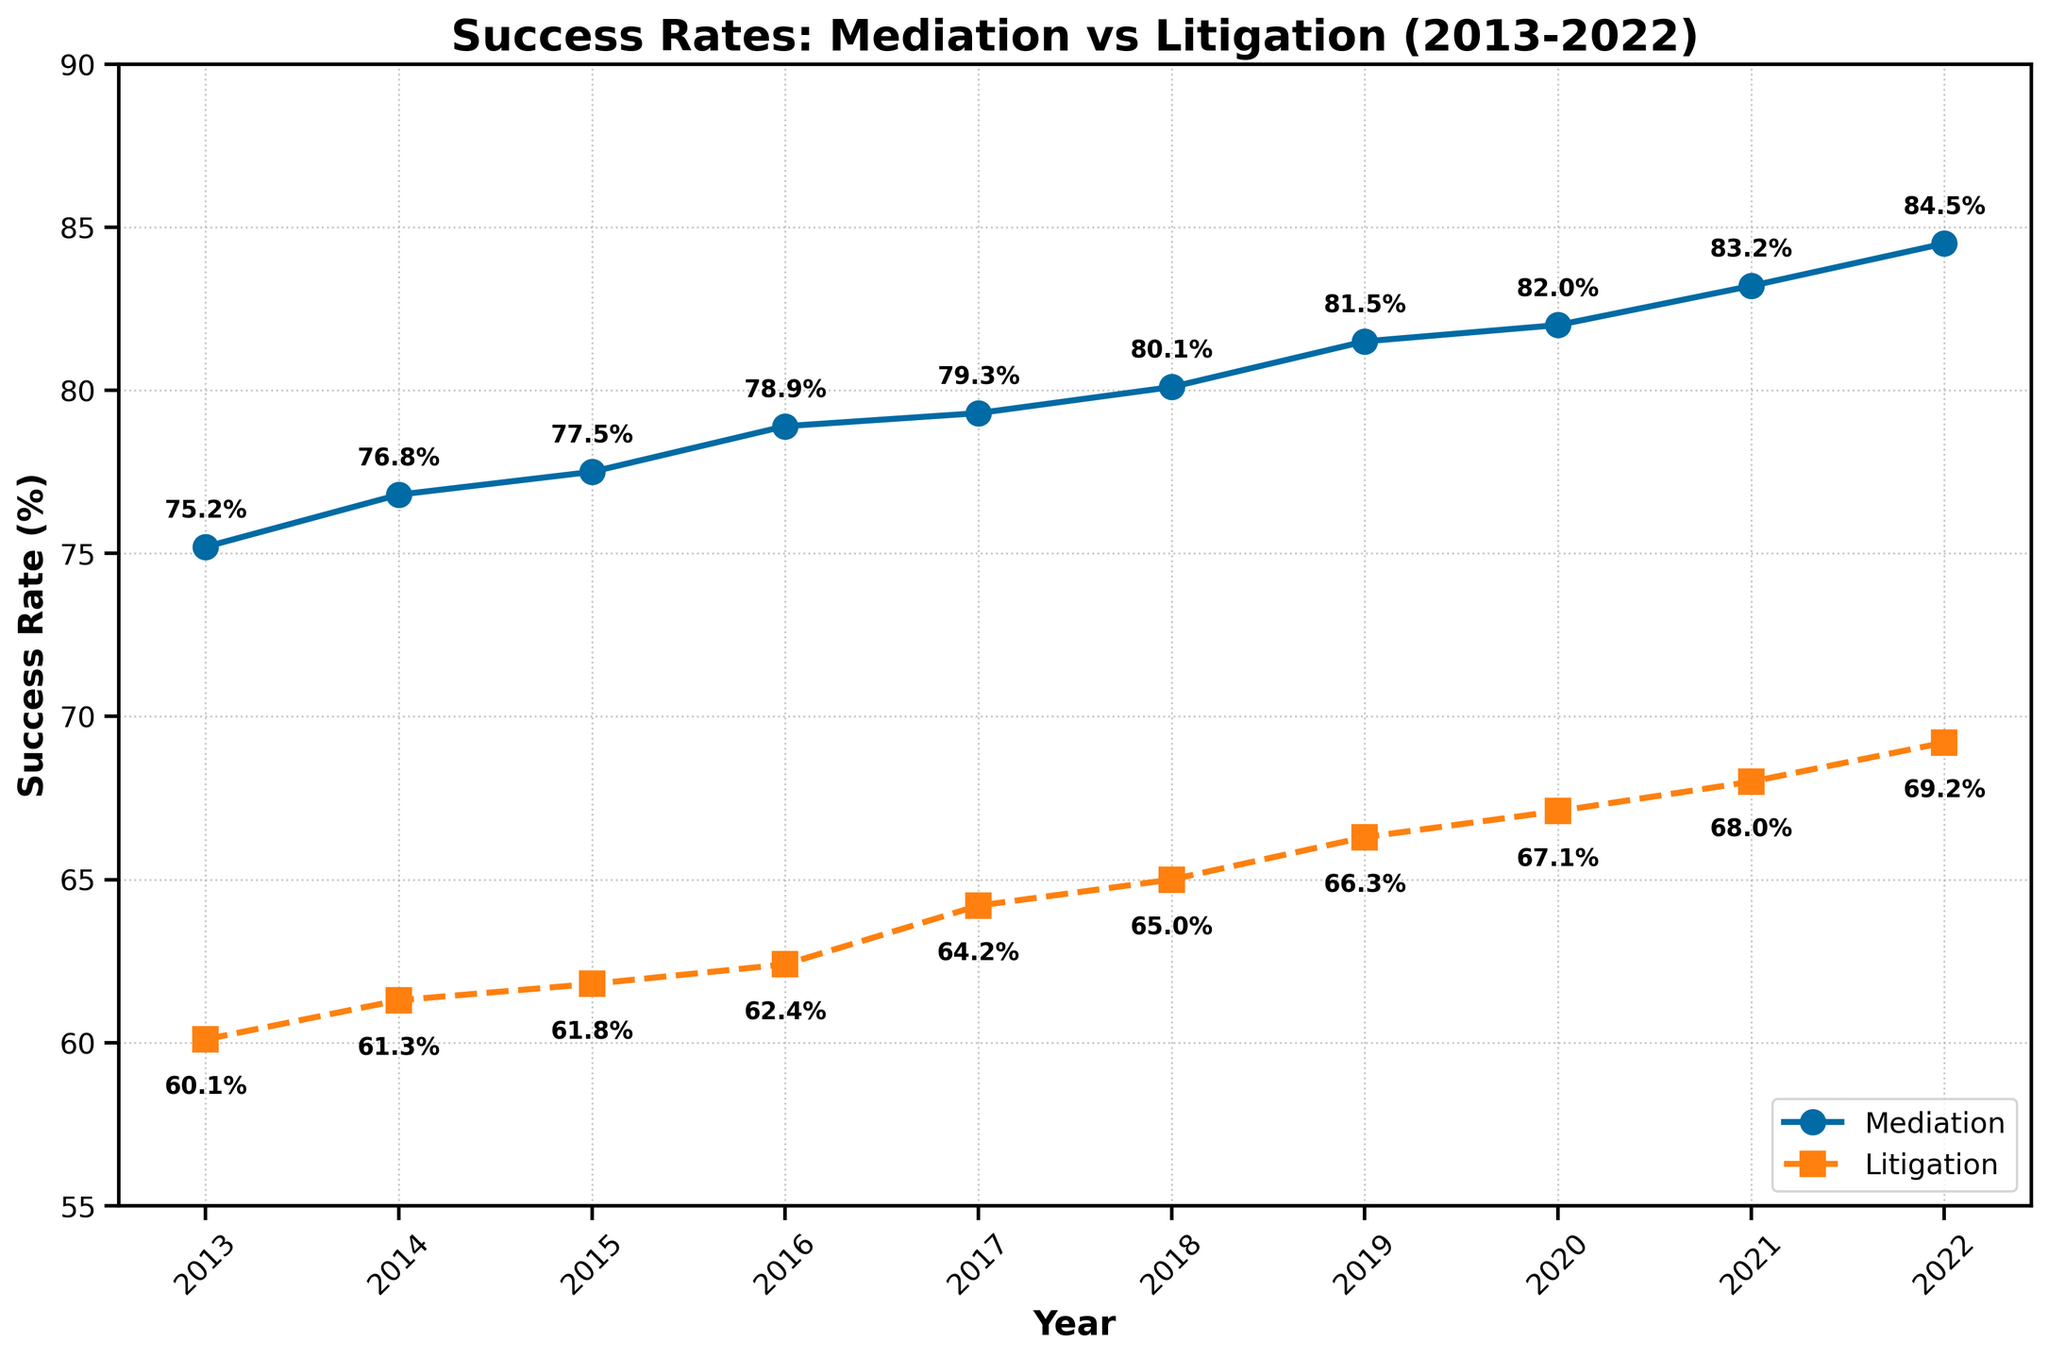what year has the highest mediation success rate? By looking at the Mediation line on the plot, the highest point will indicate the highest success rate. The highest success rate on the Mediation line is in the year 2022.
Answer: 2022 what is the difference in success rates between mediation and litigation in 2017? Identify the success rates for both Mediation and Litigation for the year 2017 on the plot: Mediation (79.3%) and Litigation (64.2%). Subtract the Litigation rate from the Mediation rate: 79.3% - 64.2% = 15.1%.
Answer: 15.1% how does the success rate change for mediation from 2013 to 2022? To find the change, look at the mediation success rates in 2013 (75.2%) and 2022 (84.5%). Subtract the 2013 rate from the 2022 rate: 84.5% - 75.2% = 9.3%.
Answer: 9.3% which year had the largest improvement in mediation success rate compared to the previous year? Check the differences year-to-year by subtracting the previous year's success rate from the current year's rate. The largest difference is between 2021 and 2022: 84.5% - 83.2% = 1.3%.
Answer: 2022 in which year did litigation success rate surpass 65% for the first time? Identify the year when the Litigation line first goes above 65%. According to the plot, the Litigation success rate surpasses 65% in 2018.
Answer: 2018 what is the trend for litigation success rates over the past decade? Observe the Litigation line from 2013 to 2022, which shows a continuous upward trend. The success rate increases each year, demonstrating a positive trend.
Answer: continuous upward trend what is the average success rate for mediation over the decade? Sum all the mediation success rates: 75.2% + 76.8% + 77.5% + 78.9% + 79.3% + 80.1% + 81.5% + 82.0% + 83.2% + 84.5% = 799.0%. Then, divide by the number of years (10): 799.0% / 10 = 79.9%.
Answer: 79.9% is the success rate of mediation always higher than litigation for every year in the decade? By comparing the Mediation and Litigation lines year by year, it is clear that for each year from 2013 to 2022, the Mediation success rate is higher than the Litigation success rate.
Answer: yes what's the median success rate of litigation from 2013 to 2022? List out the success rates for Litigation: 60.1%, 61.3%, 61.8%, 62.4%, 64.2%, 65.0%, 66.3%, 67.1%, 68.0%, 69.2%. Since there are 10 data points, the median will be the average of the 5th and 6th values (64.2% and 65.0%): (64.2% + 65.0%)/2 = 64.6%.
Answer: 64.6% how many years have both mediation and litigation success rates been above 70%? Check each year in the plot. The Mediation success rate is above 70% for every year from 2013 to 2022. The Litigation success rate only surpasses 70% in 2022, so only one year meets the criteria.
Answer: 1 